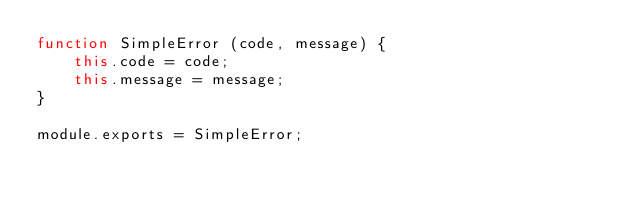Convert code to text. <code><loc_0><loc_0><loc_500><loc_500><_JavaScript_>function SimpleError (code, message) {
    this.code = code;
    this.message = message;
}

module.exports = SimpleError;
</code> 